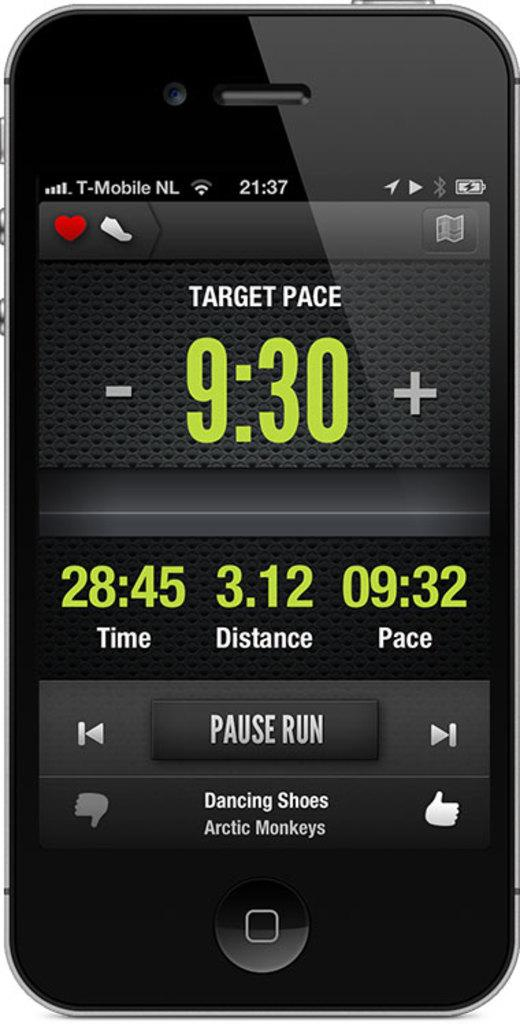<image>
Provide a brief description of the given image. A cell phone screen shows the Target Pace of a run and a distance of 3.12. 